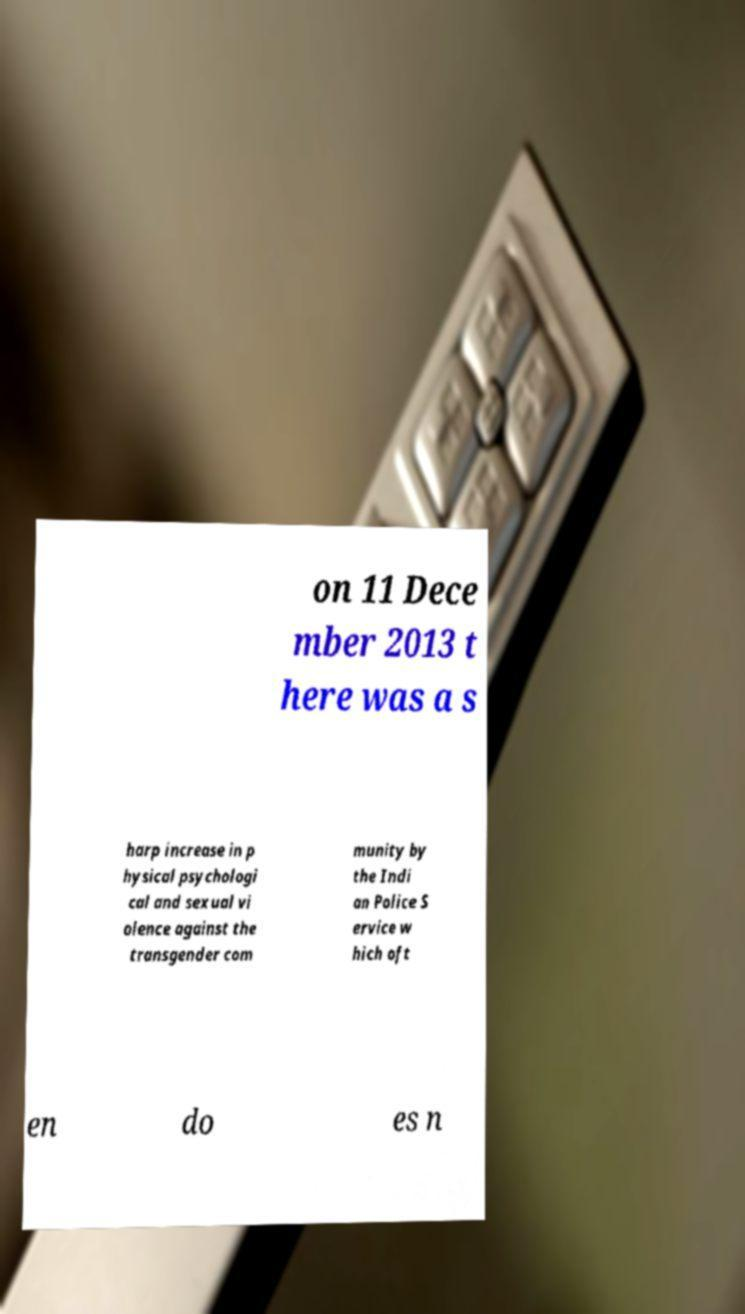What messages or text are displayed in this image? I need them in a readable, typed format. on 11 Dece mber 2013 t here was a s harp increase in p hysical psychologi cal and sexual vi olence against the transgender com munity by the Indi an Police S ervice w hich oft en do es n 